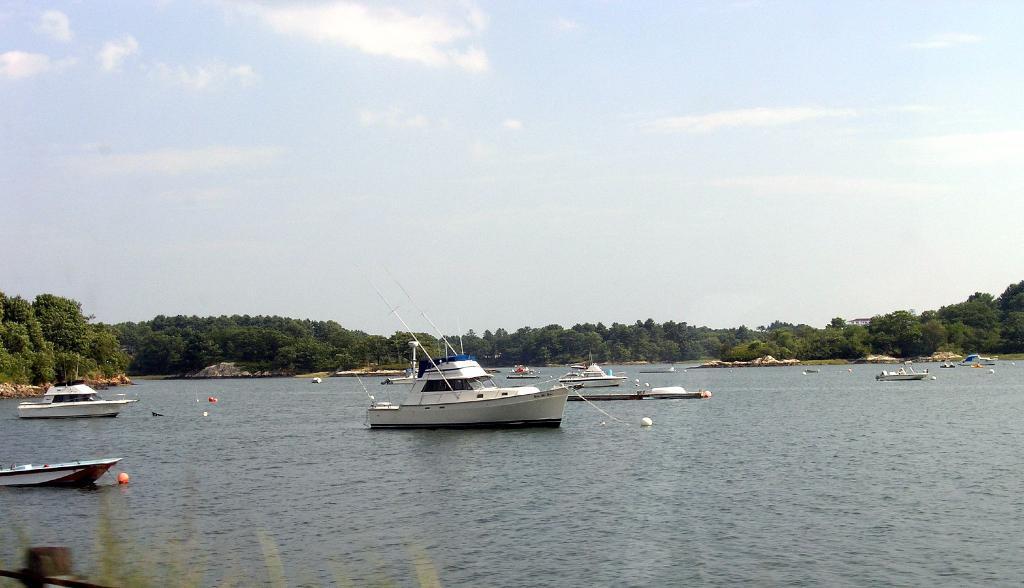Please provide a concise description of this image. in the foreground of the picture there is a water body, in the water we can see lot of boats. In the middle of the picture there are trees. At the top there is sky. 